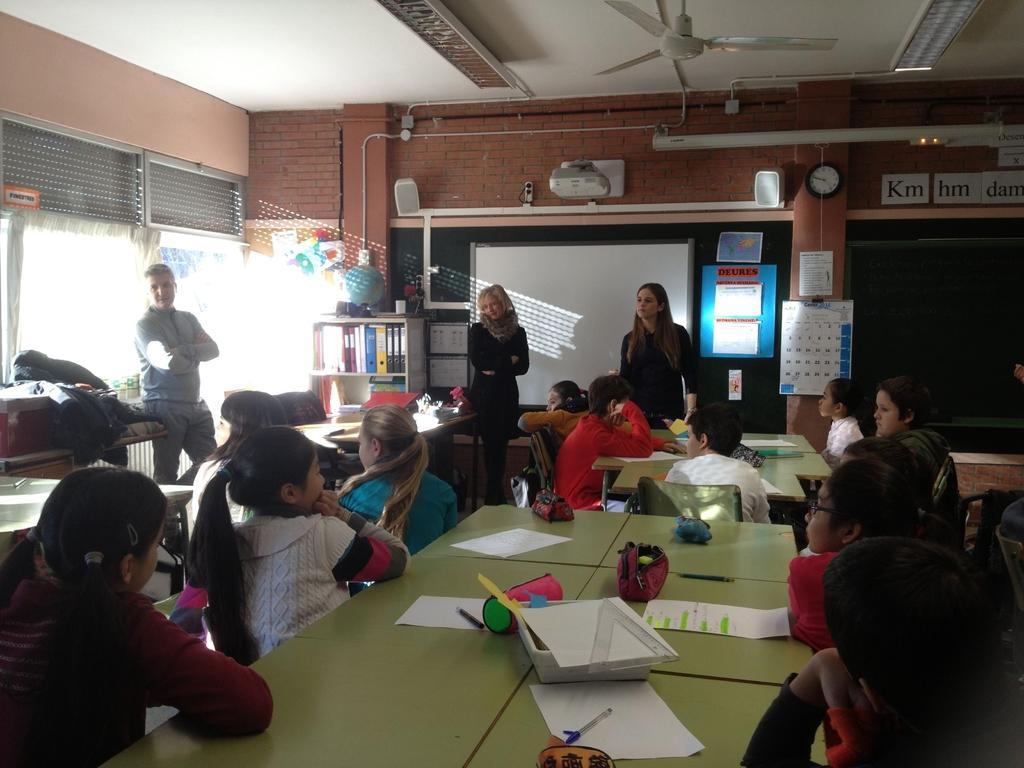Could you give a brief overview of what you see in this image? This image is taken indoors. At the bottom of the image there is a table with a few things on it. In the middle of the image a few kids are sitting on the chairs and there are a few tables with a few things on them and two women and a man are standing on the floor. In the background there are a few walls with windows and curtains and there are a few posters and papers with a text on them. There is a cupboard with a few files in it. At the top of the image there is a ceiling with a fan. 